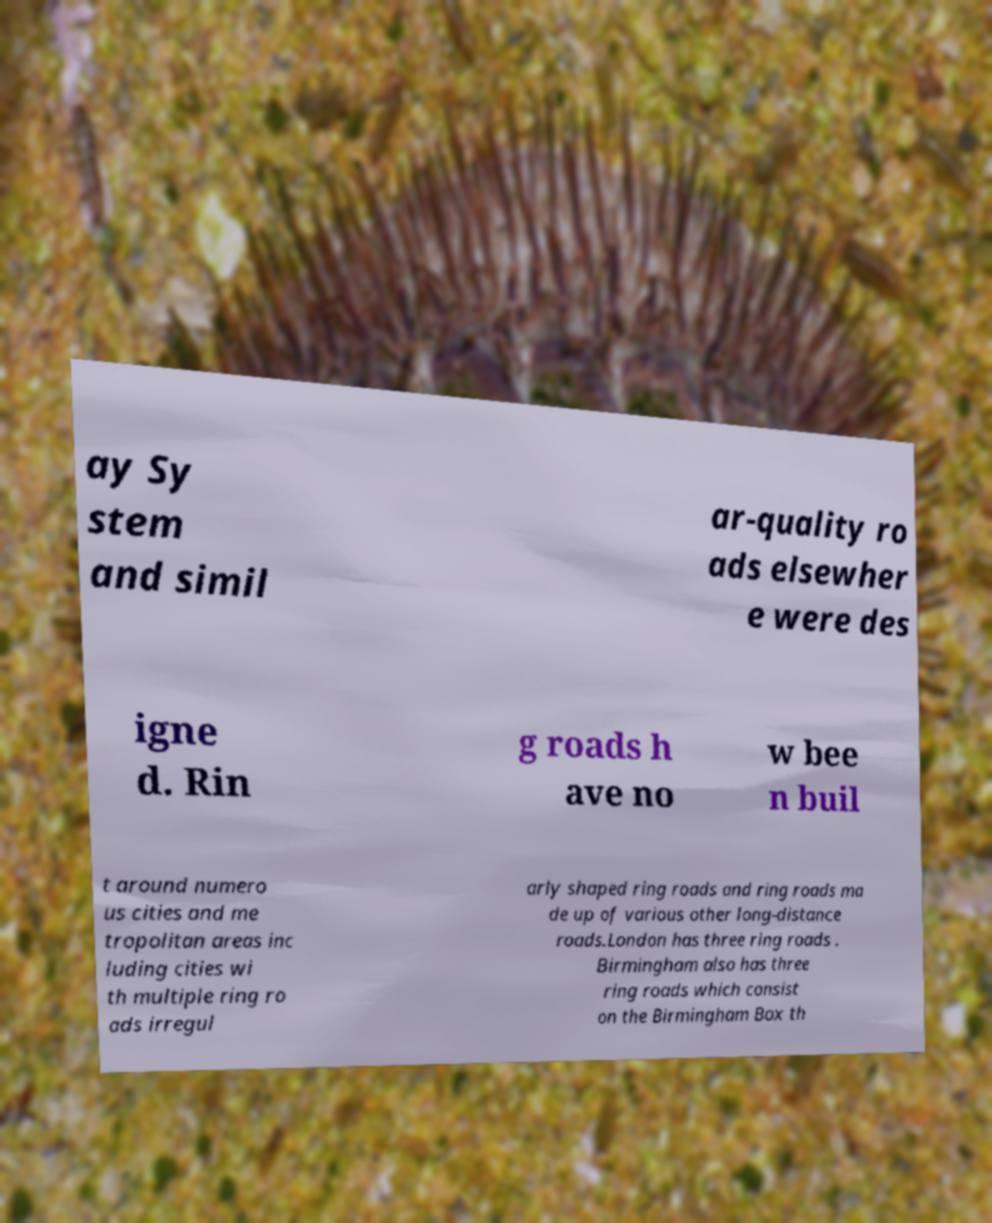What messages or text are displayed in this image? I need them in a readable, typed format. ay Sy stem and simil ar-quality ro ads elsewher e were des igne d. Rin g roads h ave no w bee n buil t around numero us cities and me tropolitan areas inc luding cities wi th multiple ring ro ads irregul arly shaped ring roads and ring roads ma de up of various other long-distance roads.London has three ring roads . Birmingham also has three ring roads which consist on the Birmingham Box th 